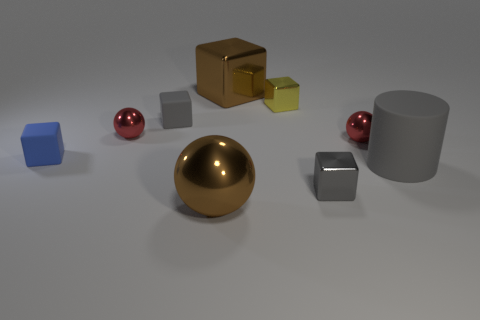Is the shape of the blue matte object the same as the brown metal thing behind the large rubber object?
Your answer should be compact. Yes. There is a tiny cube that is on the left side of the small gray block behind the gray metallic object on the left side of the big gray matte cylinder; what is its material?
Offer a very short reply. Rubber. What number of tiny things are there?
Keep it short and to the point. 6. How many cyan objects are small things or tiny shiny cubes?
Ensure brevity in your answer.  0. How many other objects are the same shape as the tiny yellow object?
Make the answer very short. 4. Do the large shiny thing behind the big sphere and the large thing that is in front of the small gray shiny block have the same color?
Ensure brevity in your answer.  Yes. What number of small things are either blue cubes or gray objects?
Ensure brevity in your answer.  3. There is a yellow metallic object that is the same shape as the blue matte thing; what is its size?
Your response must be concise. Small. There is a large gray cylinder that is in front of the matte block on the right side of the blue rubber thing; what is its material?
Your answer should be compact. Rubber. How many metal things are small blue things or small blocks?
Ensure brevity in your answer.  2. 